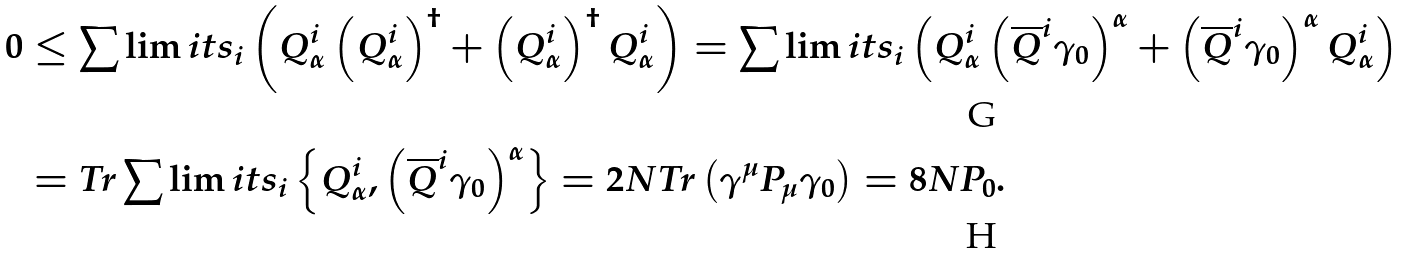<formula> <loc_0><loc_0><loc_500><loc_500>0 & \leq \sum \lim i t s _ { i } \left ( Q _ { \alpha } ^ { i } \left ( Q _ { \alpha } ^ { i } \right ) ^ { \dagger } + \left ( Q _ { \alpha } ^ { i } \right ) ^ { \dagger } Q _ { \alpha } ^ { i } \right ) = \sum \lim i t s _ { i } \left ( Q _ { \alpha } ^ { i } \left ( \overline { Q } ^ { i } \gamma _ { 0 } \right ) ^ { \alpha } + \left ( \overline { Q } ^ { i } \gamma _ { 0 } \right ) ^ { \alpha } Q _ { \alpha } ^ { i } \right ) \\ & = T r \sum \lim i t s _ { i } \left \{ Q _ { \alpha } ^ { i } , \left ( \overline { Q } ^ { i } \gamma _ { 0 } \right ) ^ { \alpha } \right \} = 2 N T r \left ( \gamma ^ { \mu } P _ { \mu } \gamma _ { 0 } \right ) = 8 N P _ { 0 } .</formula> 